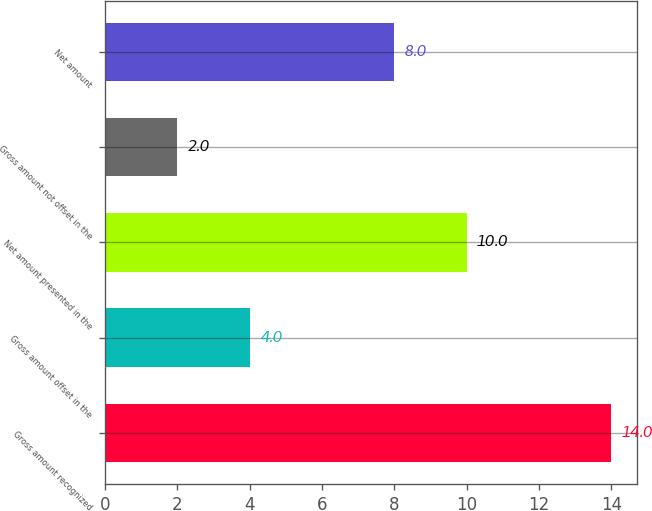Convert chart to OTSL. <chart><loc_0><loc_0><loc_500><loc_500><bar_chart><fcel>Gross amount recognized<fcel>Gross amount offset in the<fcel>Net amount presented in the<fcel>Gross amount not offset in the<fcel>Net amount<nl><fcel>14<fcel>4<fcel>10<fcel>2<fcel>8<nl></chart> 